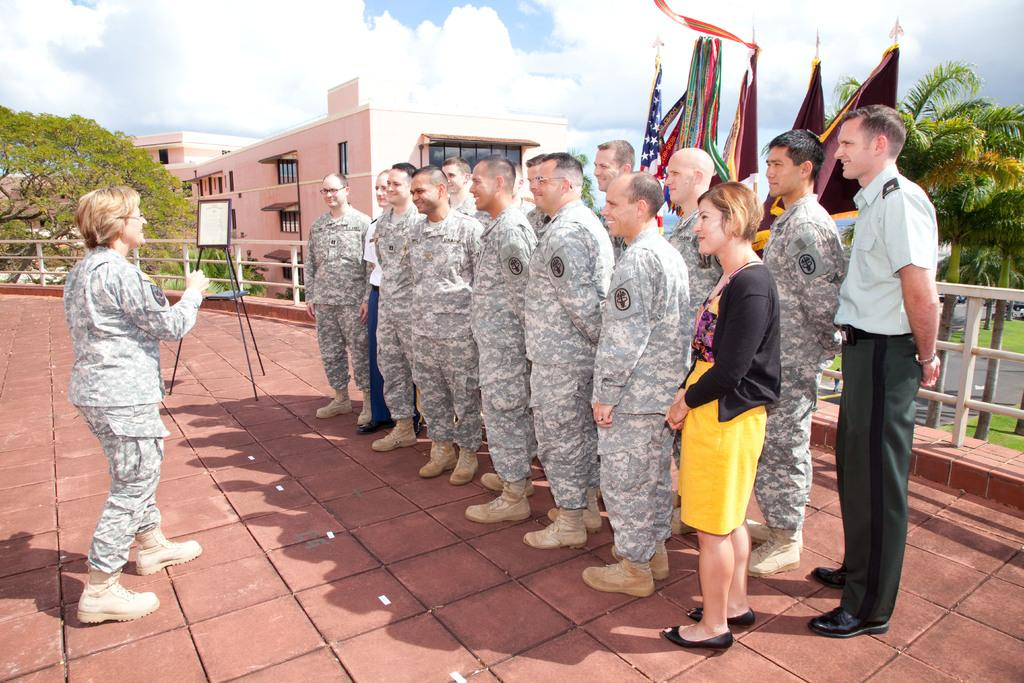What are the people in the image doing? The people in the image are standing and smiling. What can be seen in the background of the image? There are trees, the ground, buildings, flags, and the sky visible in the background of the image. What is the condition of the sky in the image? The sky is visible in the background of the image, and clouds are present. What type of badge can be seen on the people in the image? There are no badges visible on the people in the image. How many times do the people in the image bite into the scene? There is no scene being bitten into in the image, and the people are not performing any such action. 